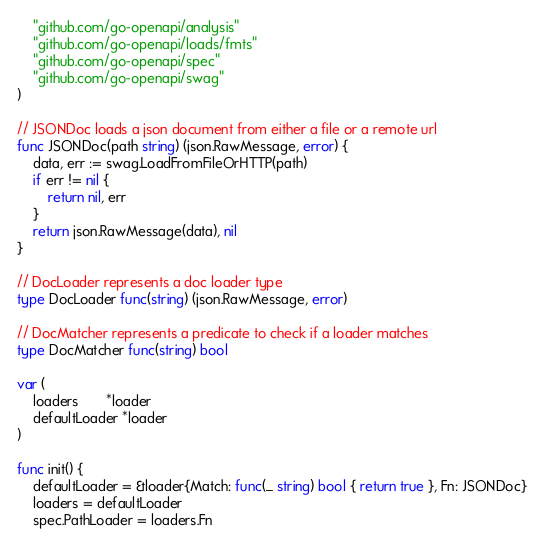Convert code to text. <code><loc_0><loc_0><loc_500><loc_500><_Go_>
	"github.com/go-openapi/analysis"
	"github.com/go-openapi/loads/fmts"
	"github.com/go-openapi/spec"
	"github.com/go-openapi/swag"
)

// JSONDoc loads a json document from either a file or a remote url
func JSONDoc(path string) (json.RawMessage, error) {
	data, err := swag.LoadFromFileOrHTTP(path)
	if err != nil {
		return nil, err
	}
	return json.RawMessage(data), nil
}

// DocLoader represents a doc loader type
type DocLoader func(string) (json.RawMessage, error)

// DocMatcher represents a predicate to check if a loader matches
type DocMatcher func(string) bool

var (
	loaders       *loader
	defaultLoader *loader
)

func init() {
	defaultLoader = &loader{Match: func(_ string) bool { return true }, Fn: JSONDoc}
	loaders = defaultLoader
	spec.PathLoader = loaders.Fn</code> 